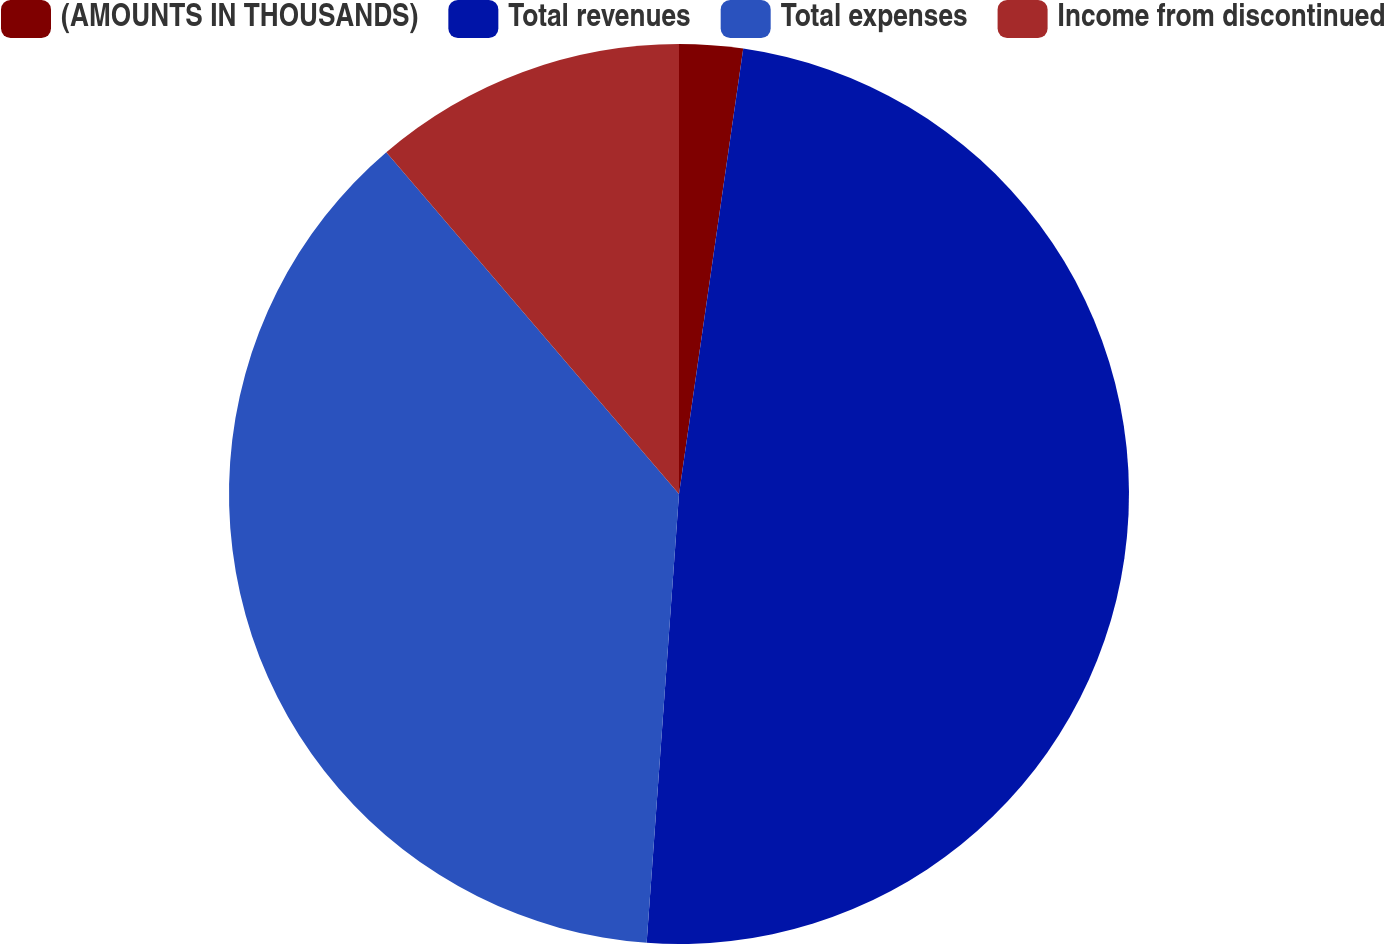<chart> <loc_0><loc_0><loc_500><loc_500><pie_chart><fcel>(AMOUNTS IN THOUSANDS)<fcel>Total revenues<fcel>Total expenses<fcel>Income from discontinued<nl><fcel>2.28%<fcel>48.86%<fcel>37.58%<fcel>11.27%<nl></chart> 